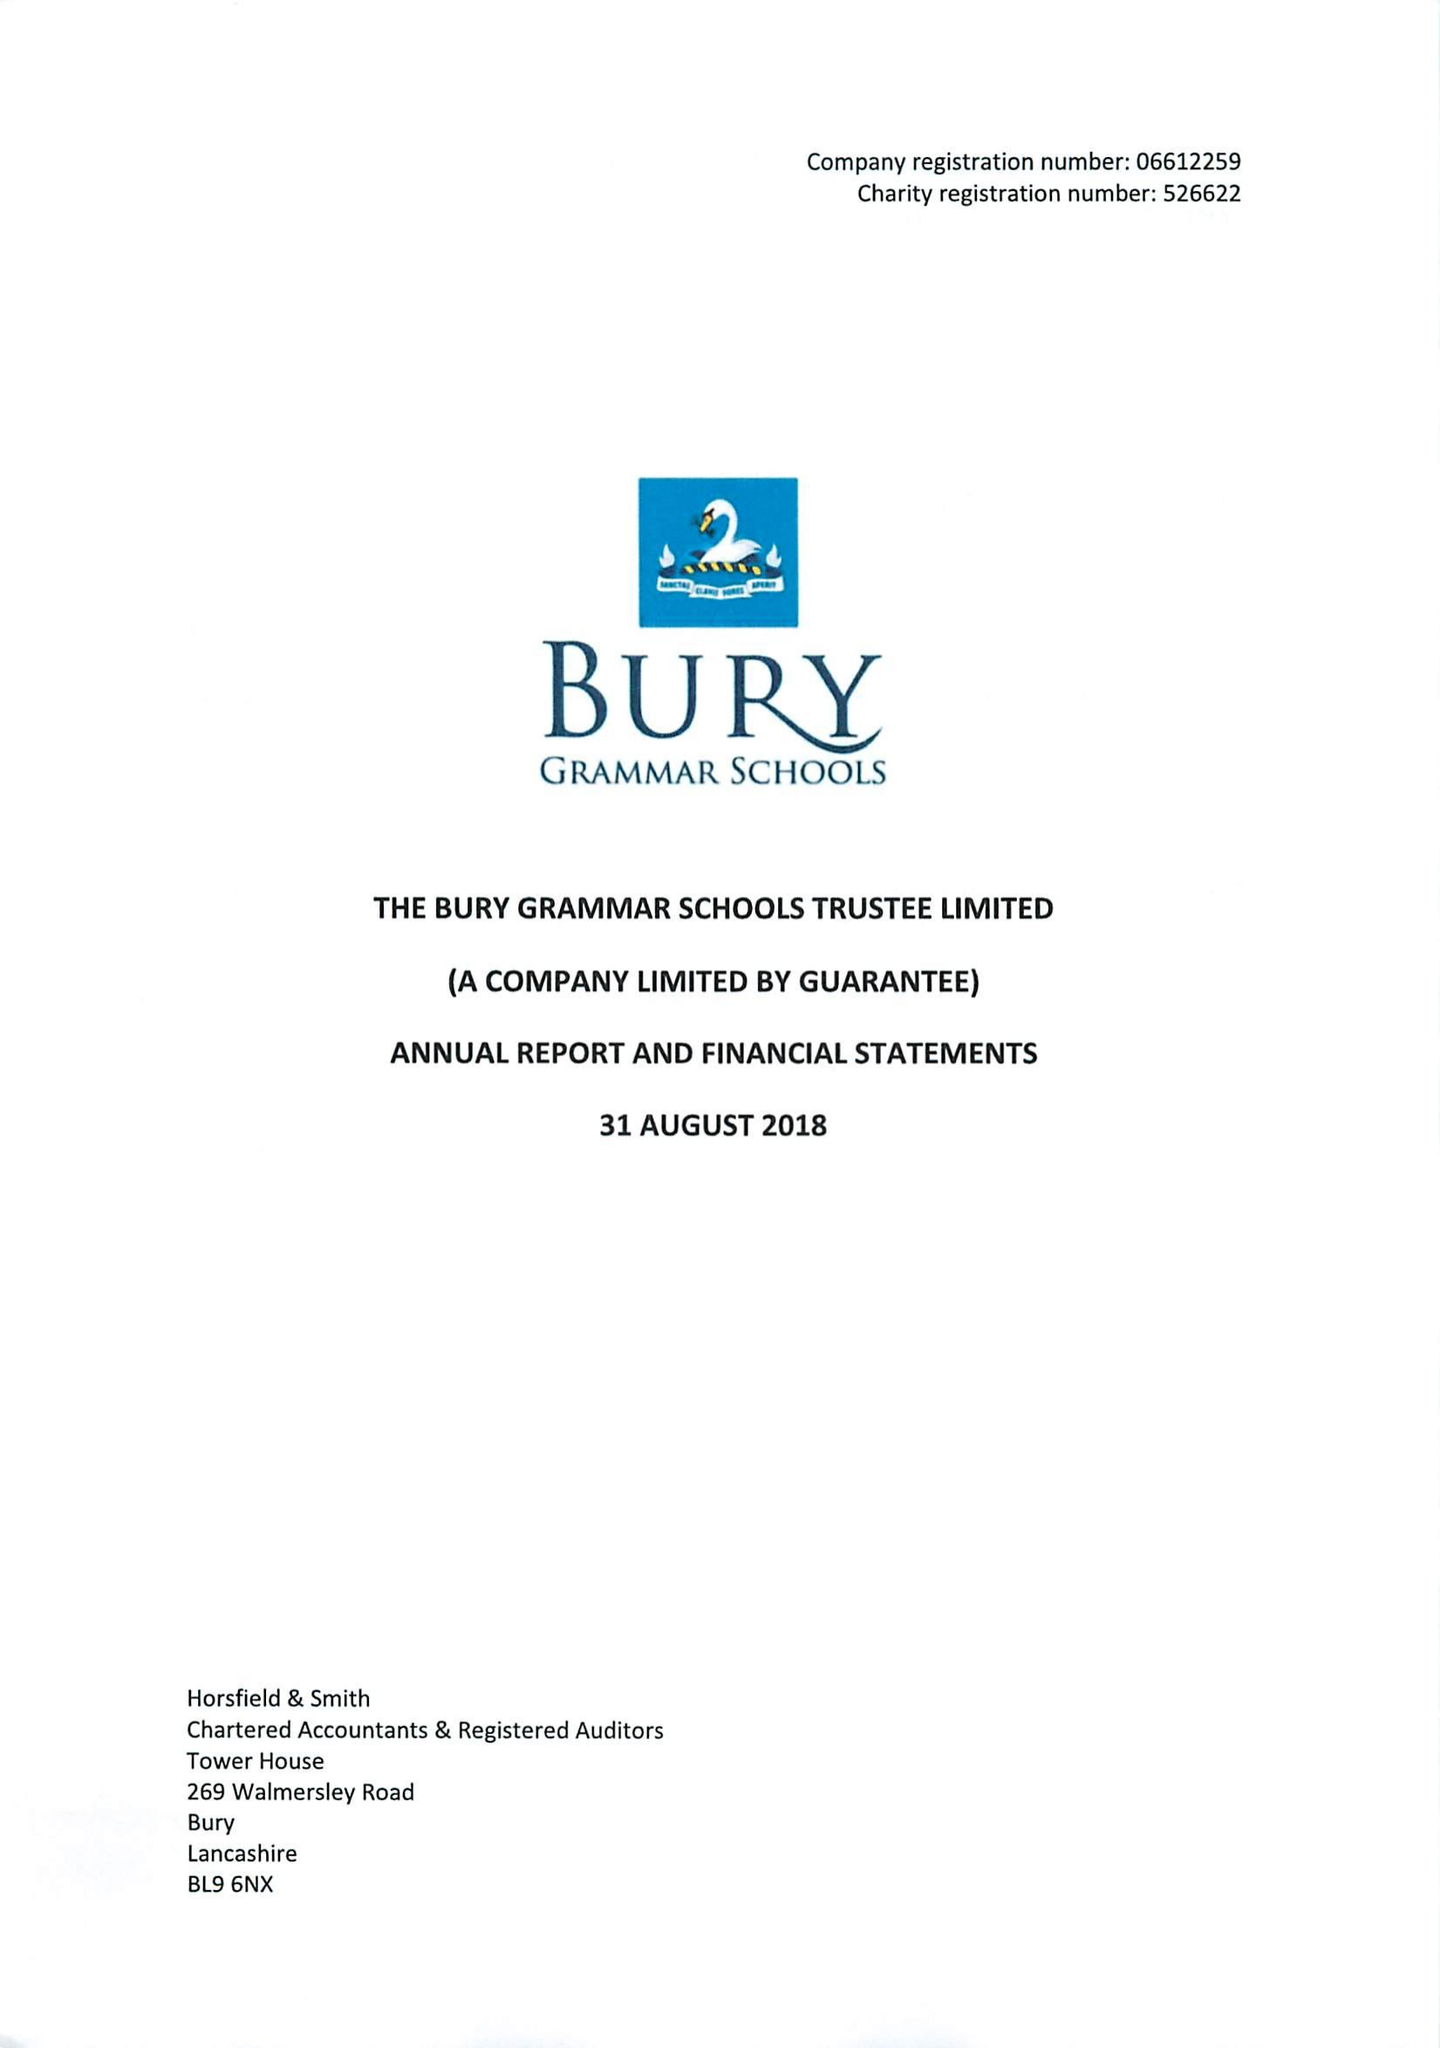What is the value for the address__street_line?
Answer the question using a single word or phrase. BRIDGE ROAD 